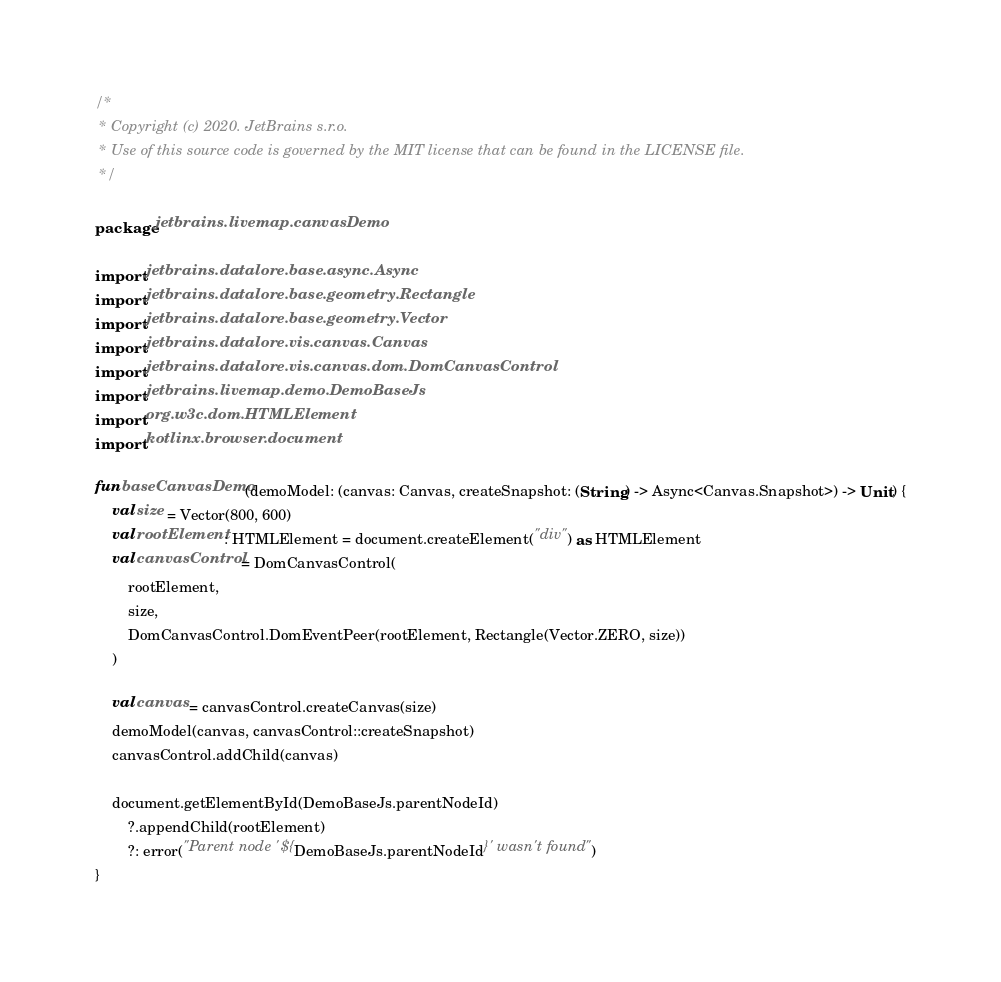Convert code to text. <code><loc_0><loc_0><loc_500><loc_500><_Kotlin_>/*
 * Copyright (c) 2020. JetBrains s.r.o.
 * Use of this source code is governed by the MIT license that can be found in the LICENSE file.
 */

package jetbrains.livemap.canvasDemo

import jetbrains.datalore.base.async.Async
import jetbrains.datalore.base.geometry.Rectangle
import jetbrains.datalore.base.geometry.Vector
import jetbrains.datalore.vis.canvas.Canvas
import jetbrains.datalore.vis.canvas.dom.DomCanvasControl
import jetbrains.livemap.demo.DemoBaseJs
import org.w3c.dom.HTMLElement
import kotlinx.browser.document

fun baseCanvasDemo(demoModel: (canvas: Canvas, createSnapshot: (String) -> Async<Canvas.Snapshot>) -> Unit) {
    val size = Vector(800, 600)
    val rootElement: HTMLElement = document.createElement("div") as HTMLElement
    val canvasControl = DomCanvasControl(
        rootElement,
        size,
        DomCanvasControl.DomEventPeer(rootElement, Rectangle(Vector.ZERO, size))
    )

    val canvas = canvasControl.createCanvas(size)
    demoModel(canvas, canvasControl::createSnapshot)
    canvasControl.addChild(canvas)

    document.getElementById(DemoBaseJs.parentNodeId)
        ?.appendChild(rootElement)
        ?: error("Parent node '${DemoBaseJs.parentNodeId}' wasn't found")
}</code> 